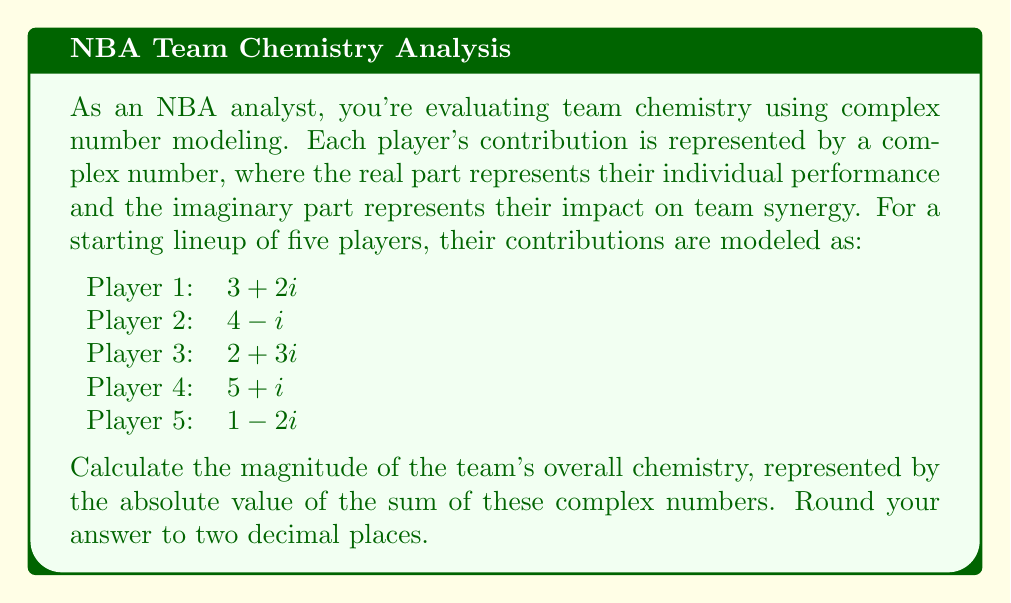Can you solve this math problem? To solve this problem, we need to follow these steps:

1) First, we sum up all the complex numbers representing each player's contribution:

   $$(3 + 2i) + (4 - i) + (2 + 3i) + (5 + i) + (1 - 2i)$$

2) Simplify by combining like terms:
   
   Real parts: $3 + 4 + 2 + 5 + 1 = 15$
   Imaginary parts: $2i - i + 3i + i - 2i = 3i$

   The sum is: $15 + 3i$

3) To find the magnitude (absolute value) of this complex number, we use the formula:

   $$|a + bi| = \sqrt{a^2 + b^2}$$

   Where $a$ is the real part and $b$ is the coefficient of the imaginary part.

4) Substituting our values:

   $$|15 + 3i| = \sqrt{15^2 + 3^2}$$

5) Calculate:

   $$\sqrt{225 + 9} = \sqrt{234}$$

6) Simplify:

   $$\sqrt{234} \approx 15.2970$$

7) Rounding to two decimal places:

   $15.30$

This final value represents the magnitude of the team's overall chemistry, combining both individual performance and synergistic effects.
Answer: $15.30$ 